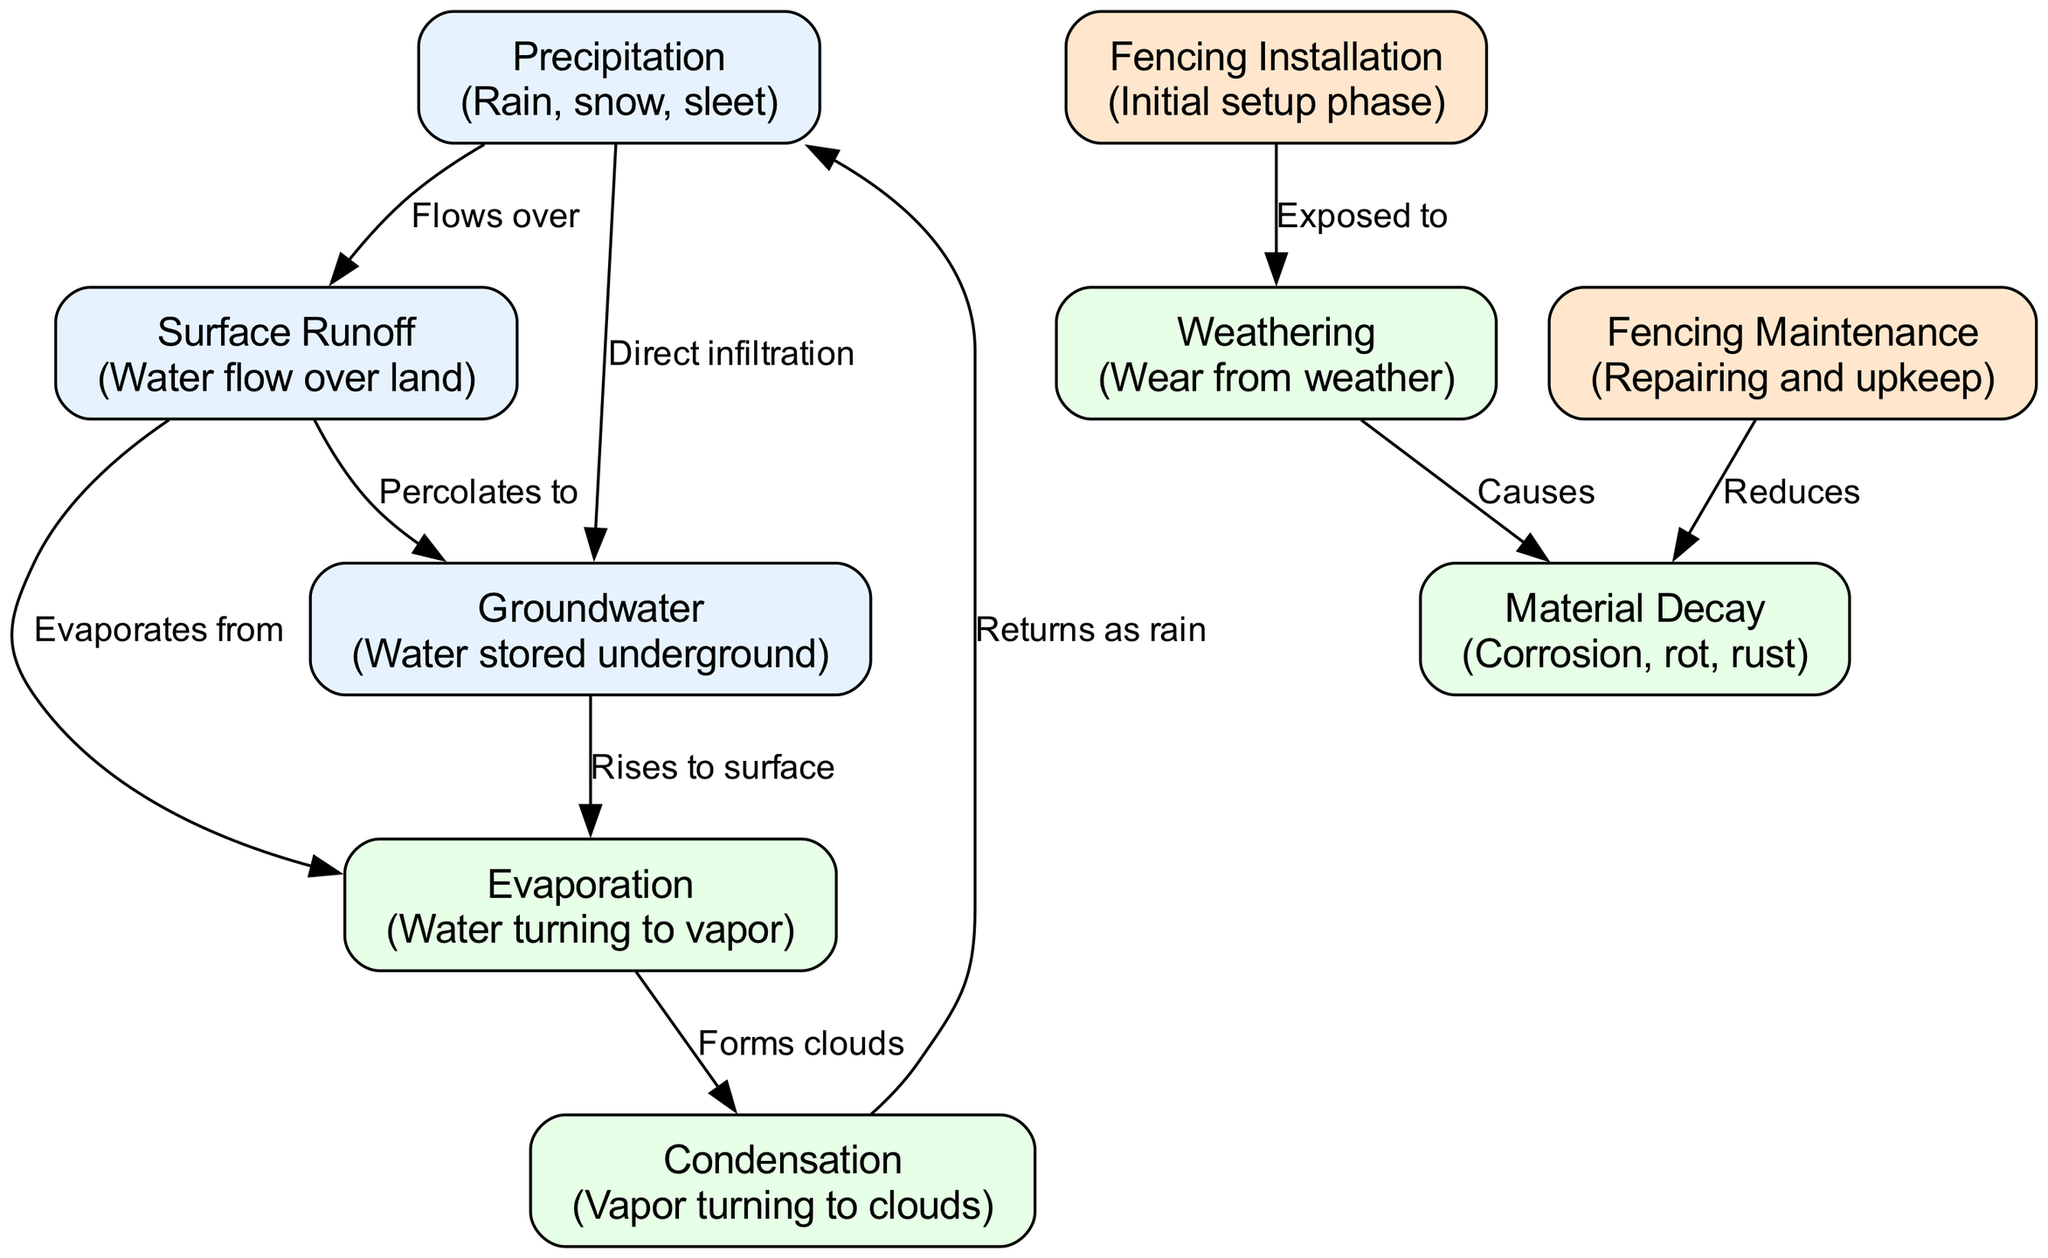What processes are involved in the water cycle depicted in the diagram? The diagram includes six main processes: precipitation, surface runoff, groundwater, evaporation, condensation, and back to precipitation. These processes demonstrate the continuous flow of water within the environment.
Answer: precipitation, surface runoff, groundwater, evaporation, condensation How many nodes are present in the diagram? The diagram includes a total of 9 nodes, each representing a distinct concept related to the water cycle and fencing wear.
Answer: 9 Which node is influenced by both precipitation and surface runoff? The groundwater node is directly connected by edges from both precipitation (direct infiltration) and surface runoff (percolates to), indicating its reliance on these factors for replenishment.
Answer: groundwater What does the weathering node cause in the context of fencing? The weathering node directly leads to material decay, which highlights its negative impact on the durability of fencing materials through processes like corrosion and rot.
Answer: material decay What activity can be performed to reduce material decay on fencing? The maintenance node is linked to material decay with a causal relationship, indicating that regular maintenance helps in reducing wear and prolonging the lifespan of fencing materials.
Answer: maintenance How does surface runoff relate to evaporation in the diagram? Surface runoff is connected to evaporation through a directed edge that states it 'evaporates from', showing that water from runoff contributes to the evaporation process.
Answer: evaporates from What returns to the atmosphere as precipitation in the diagram? The diagram indicates that condensation forms clouds, which eventually return to the earth as precipitation, showing the cyclical nature of the water process.
Answer: clouds What is the first phase shown in the diagram concerning fencing? The fencing installation node represents the initial setup phase before the fencing is exposed to environmental elements that could affect its durability.
Answer: fencing installation Which two processes are directly related to fencing installation and material decay? The fencing installation is exposed to weathering, which directly causes material decay, demonstrating the impact of environmental factors on fencing durability.
Answer: weathering, material decay 